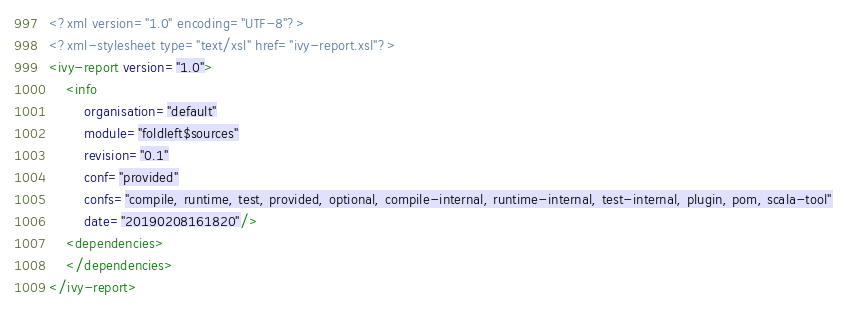Convert code to text. <code><loc_0><loc_0><loc_500><loc_500><_XML_><?xml version="1.0" encoding="UTF-8"?>
<?xml-stylesheet type="text/xsl" href="ivy-report.xsl"?>
<ivy-report version="1.0">
	<info
		organisation="default"
		module="foldleft$sources"
		revision="0.1"
		conf="provided"
		confs="compile, runtime, test, provided, optional, compile-internal, runtime-internal, test-internal, plugin, pom, scala-tool"
		date="20190208161820"/>
	<dependencies>
	</dependencies>
</ivy-report>
</code> 